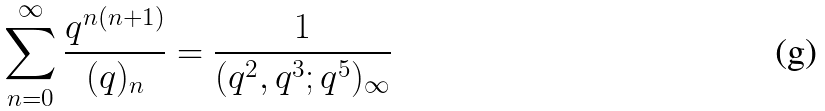<formula> <loc_0><loc_0><loc_500><loc_500>\sum _ { n = 0 } ^ { \infty } \frac { q ^ { n ( n + 1 ) } } { ( q ) _ { n } } = \frac { 1 } { ( q ^ { 2 } , q ^ { 3 } ; q ^ { 5 } ) _ { \infty } }</formula> 